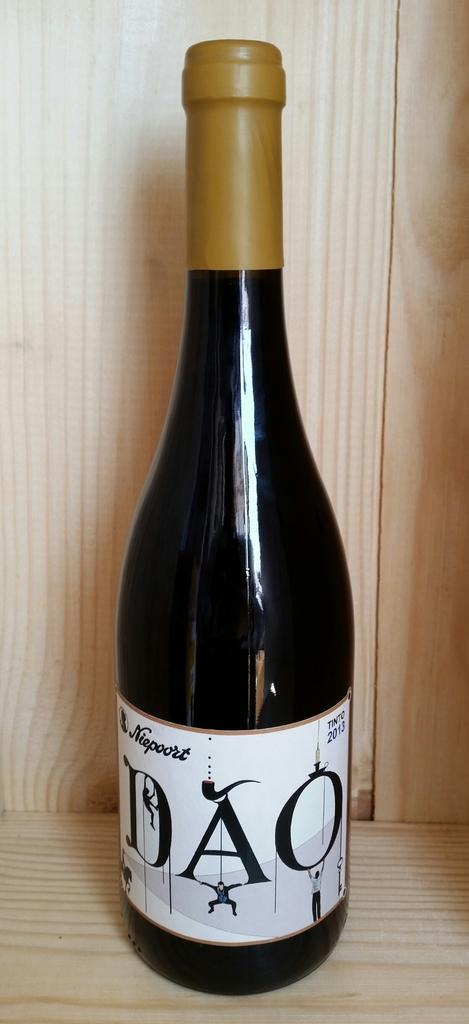<image>
Give a short and clear explanation of the subsequent image. A 2013, DAO bottle of wine is sitting on a counter. 